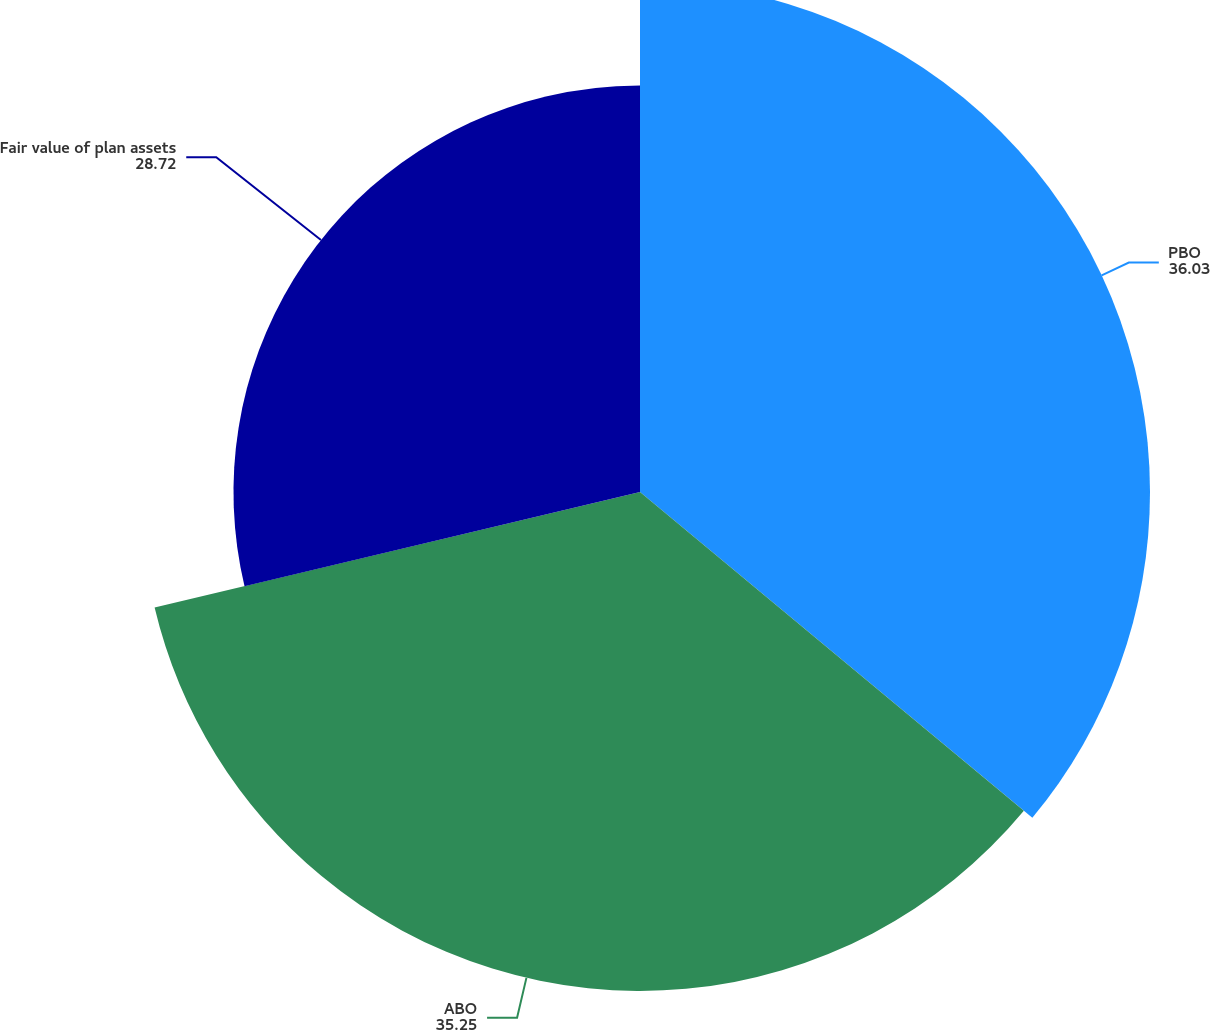Convert chart. <chart><loc_0><loc_0><loc_500><loc_500><pie_chart><fcel>PBO<fcel>ABO<fcel>Fair value of plan assets<nl><fcel>36.03%<fcel>35.25%<fcel>28.72%<nl></chart> 